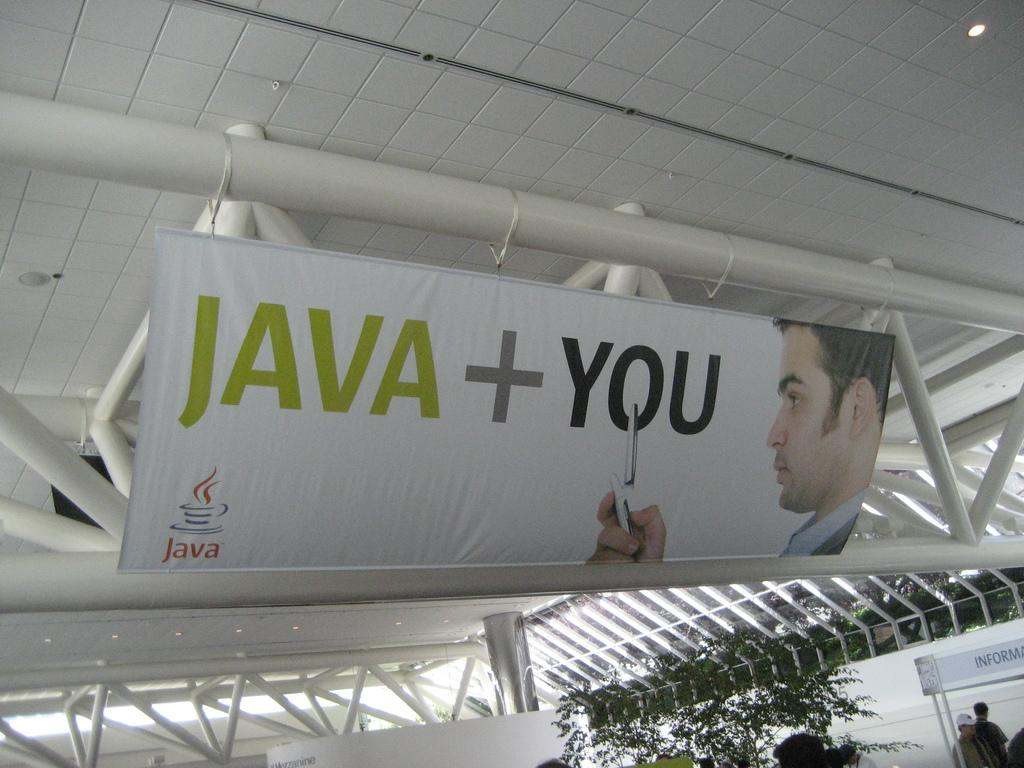<image>
Present a compact description of the photo's key features. the word you is on a white sign in a room 